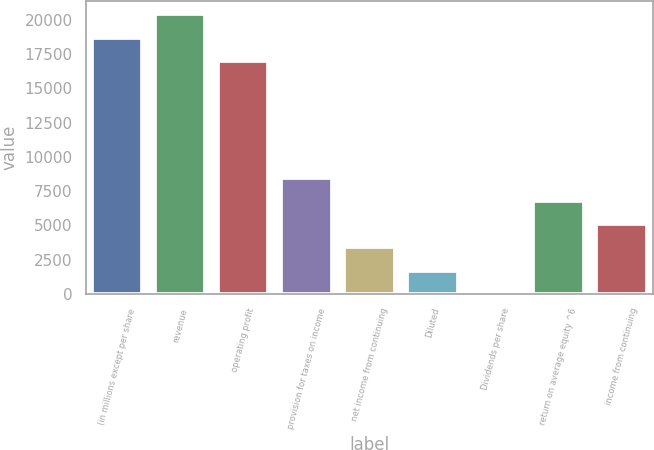Convert chart. <chart><loc_0><loc_0><loc_500><loc_500><bar_chart><fcel>(in millions except per share<fcel>revenue<fcel>operating profit<fcel>provision for taxes on income<fcel>net income from continuing<fcel>Diluted<fcel>Dividends per share<fcel>return on average equity ^6<fcel>income from continuing<nl><fcel>18699.9<fcel>20399.8<fcel>17000<fcel>8500.57<fcel>3400.9<fcel>1701.01<fcel>1.12<fcel>6800.68<fcel>5100.79<nl></chart> 